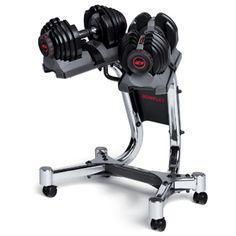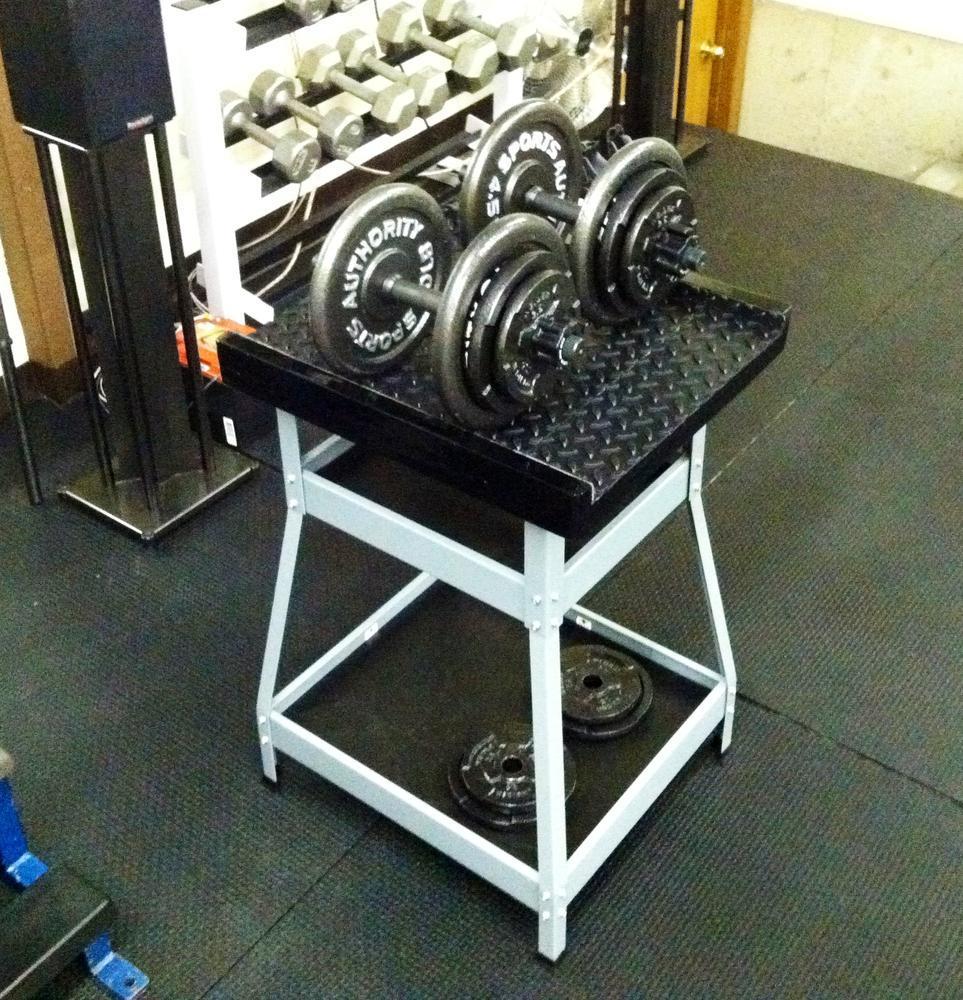The first image is the image on the left, the second image is the image on the right. Evaluate the accuracy of this statement regarding the images: "In the right image a woman is standing but kneeling towards the ground with one knee close to the floor.". Is it true? Answer yes or no. No. 